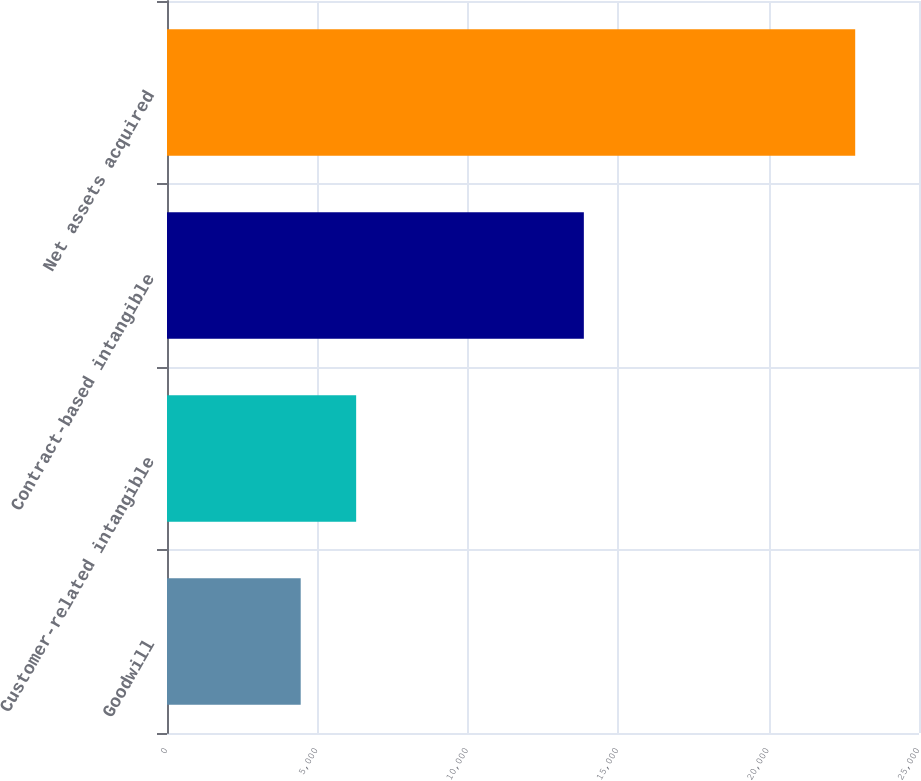<chart> <loc_0><loc_0><loc_500><loc_500><bar_chart><fcel>Goodwill<fcel>Customer-related intangible<fcel>Contract-based intangible<fcel>Net assets acquired<nl><fcel>4445<fcel>6288.4<fcel>13858<fcel>22879<nl></chart> 